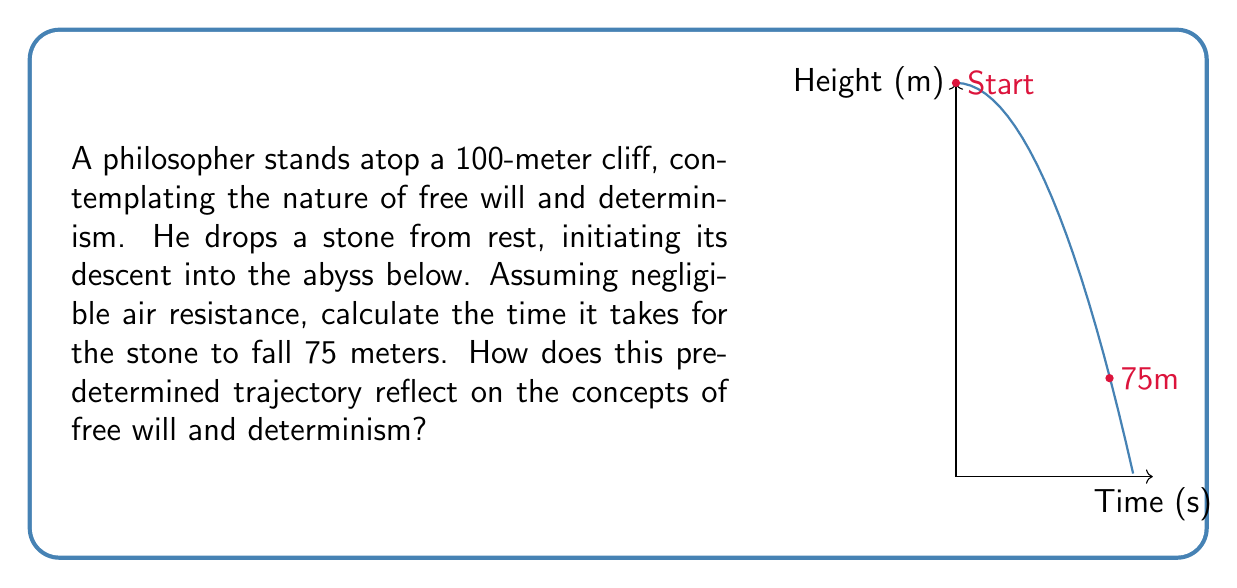Could you help me with this problem? Let's approach this step-by-step:

1) The equation for the position of a falling object under constant acceleration is:

   $$y = y_0 + v_0t - \frac{1}{2}gt^2$$

   Where:
   $y$ is the final position
   $y_0$ is the initial position
   $v_0$ is the initial velocity
   $g$ is the acceleration due to gravity (9.8 m/s²)
   $t$ is the time

2) In this case:
   $y = 25$ m (100 m - 75 m)
   $y_0 = 100$ m
   $v_0 = 0$ m/s (dropped from rest)
   $g = 9.8$ m/s²

3) Substituting these values:

   $$25 = 100 + 0 - \frac{1}{2}(9.8)t^2$$

4) Simplify:
   $$25 = 100 - 4.9t^2$$

5) Subtract 100 from both sides:
   $$-75 = -4.9t^2$$

6) Divide both sides by -4.9:
   $$15.3061 = t^2$$

7) Take the square root of both sides:
   $$t = \sqrt{15.3061} \approx 3.9125$$

The stone takes approximately 3.9125 seconds to fall 75 meters.

This predetermined trajectory, governed by the laws of physics, reflects the deterministic nature of the physical world. Just as the stone's path is determined by initial conditions and physical laws, determinism suggests that all events, including human actions, are predetermined by prior causes. However, the philosopher's decision to drop the stone might be seen as an act of free will, introducing a tension between determinism and the subjective experience of choice.
Answer: $t \approx 3.9125$ seconds 